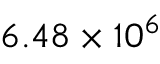Convert formula to latex. <formula><loc_0><loc_0><loc_500><loc_500>6 . 4 8 \times 1 0 ^ { 6 }</formula> 